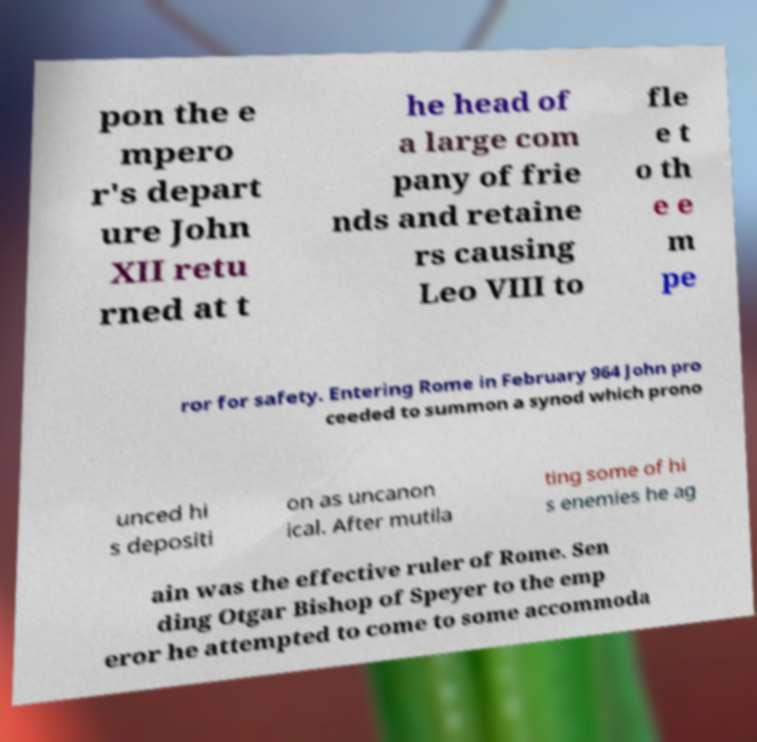Can you read and provide the text displayed in the image?This photo seems to have some interesting text. Can you extract and type it out for me? pon the e mpero r's depart ure John XII retu rned at t he head of a large com pany of frie nds and retaine rs causing Leo VIII to fle e t o th e e m pe ror for safety. Entering Rome in February 964 John pro ceeded to summon a synod which prono unced hi s depositi on as uncanon ical. After mutila ting some of hi s enemies he ag ain was the effective ruler of Rome. Sen ding Otgar Bishop of Speyer to the emp eror he attempted to come to some accommoda 